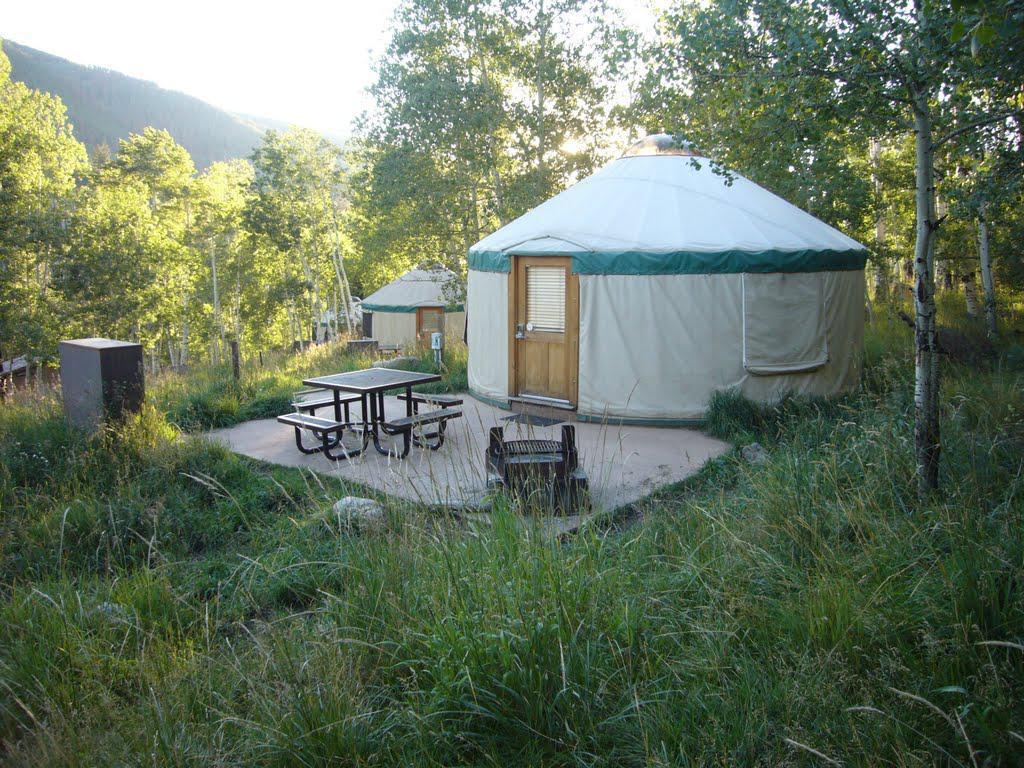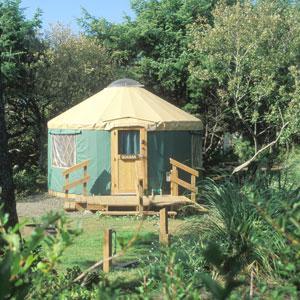The first image is the image on the left, the second image is the image on the right. Examine the images to the left and right. Is the description "There is a structure with a wooden roof to the right of the yurt in the image on the right." accurate? Answer yes or no. No. 